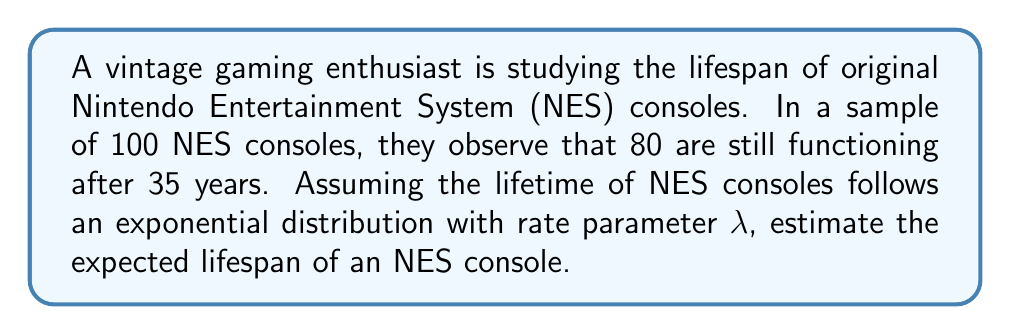What is the answer to this math problem? Let's approach this step-by-step using survival analysis:

1) The survival function for an exponential distribution is given by:

   $$S(t) = e^{-\lambda t}$$

   where $t$ is time and $\lambda$ is the rate parameter.

2) We know that after 35 years, 80 out of 100 consoles are still functioning. This gives us:

   $$S(35) = \frac{80}{100} = 0.8$$

3) Substituting into the survival function:

   $$0.8 = e^{-35\lambda}$$

4) Taking the natural log of both sides:

   $$\ln(0.8) = -35\lambda$$

5) Solving for $\lambda$:

   $$\lambda = -\frac{\ln(0.8)}{35} \approx 0.00634$$

6) For an exponential distribution, the expected value (mean lifespan) is given by:

   $$E[T] = \frac{1}{\lambda}$$

7) Substituting our calculated $\lambda$:

   $$E[T] = \frac{1}{0.00634} \approx 157.73$$

Thus, the expected lifespan of an NES console is approximately 157.73 years.
Answer: 157.73 years 